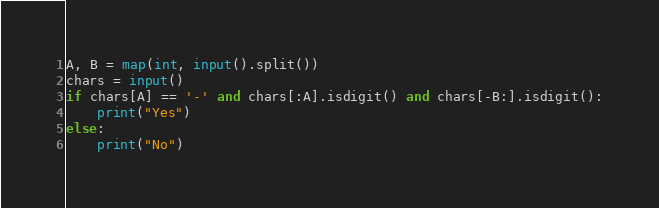Convert code to text. <code><loc_0><loc_0><loc_500><loc_500><_Python_>A, B = map(int, input().split())
chars = input()
if chars[A] == '-' and chars[:A].isdigit() and chars[-B:].isdigit():
    print("Yes")
else:
    print("No")

</code> 